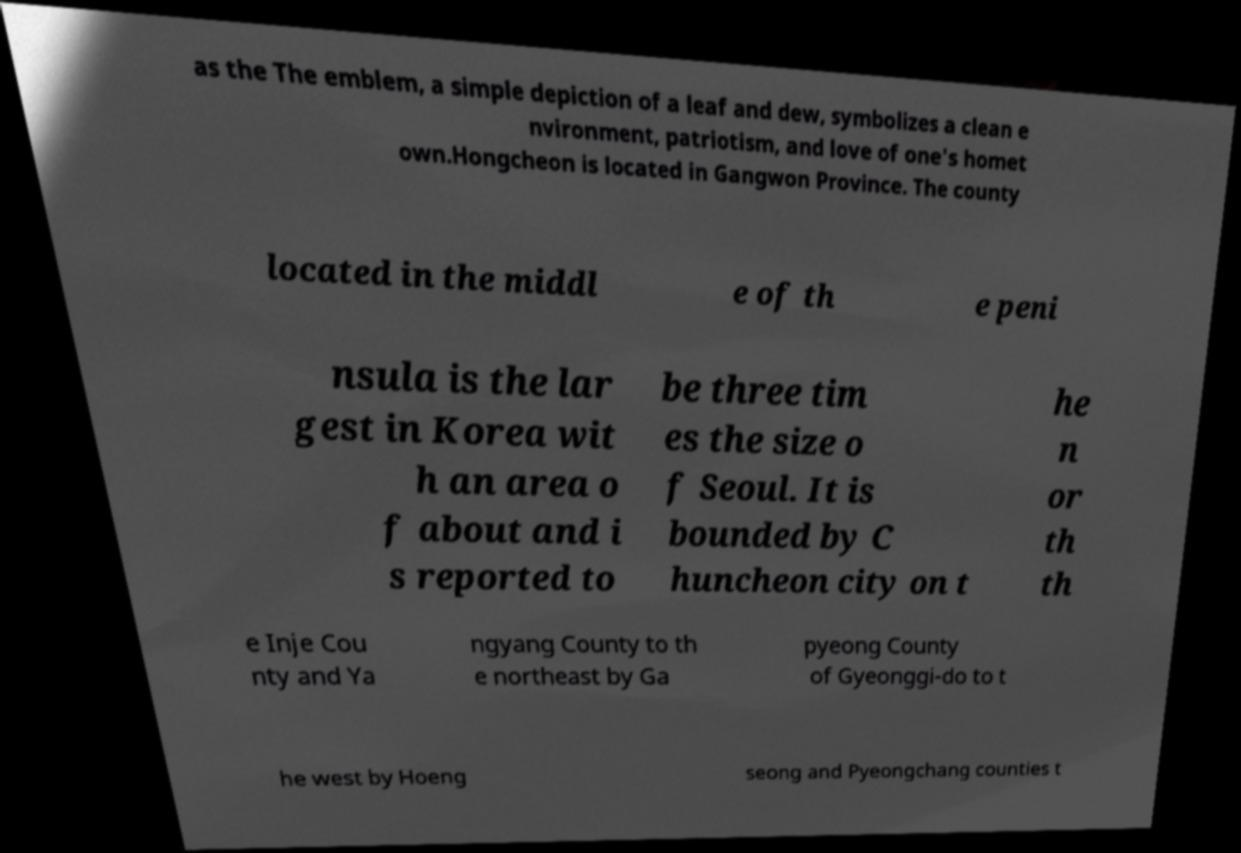Please read and relay the text visible in this image. What does it say? as the The emblem, a simple depiction of a leaf and dew, symbolizes a clean e nvironment, patriotism, and love of one's homet own.Hongcheon is located in Gangwon Province. The county located in the middl e of th e peni nsula is the lar gest in Korea wit h an area o f about and i s reported to be three tim es the size o f Seoul. It is bounded by C huncheon city on t he n or th th e Inje Cou nty and Ya ngyang County to th e northeast by Ga pyeong County of Gyeonggi-do to t he west by Hoeng seong and Pyeongchang counties t 